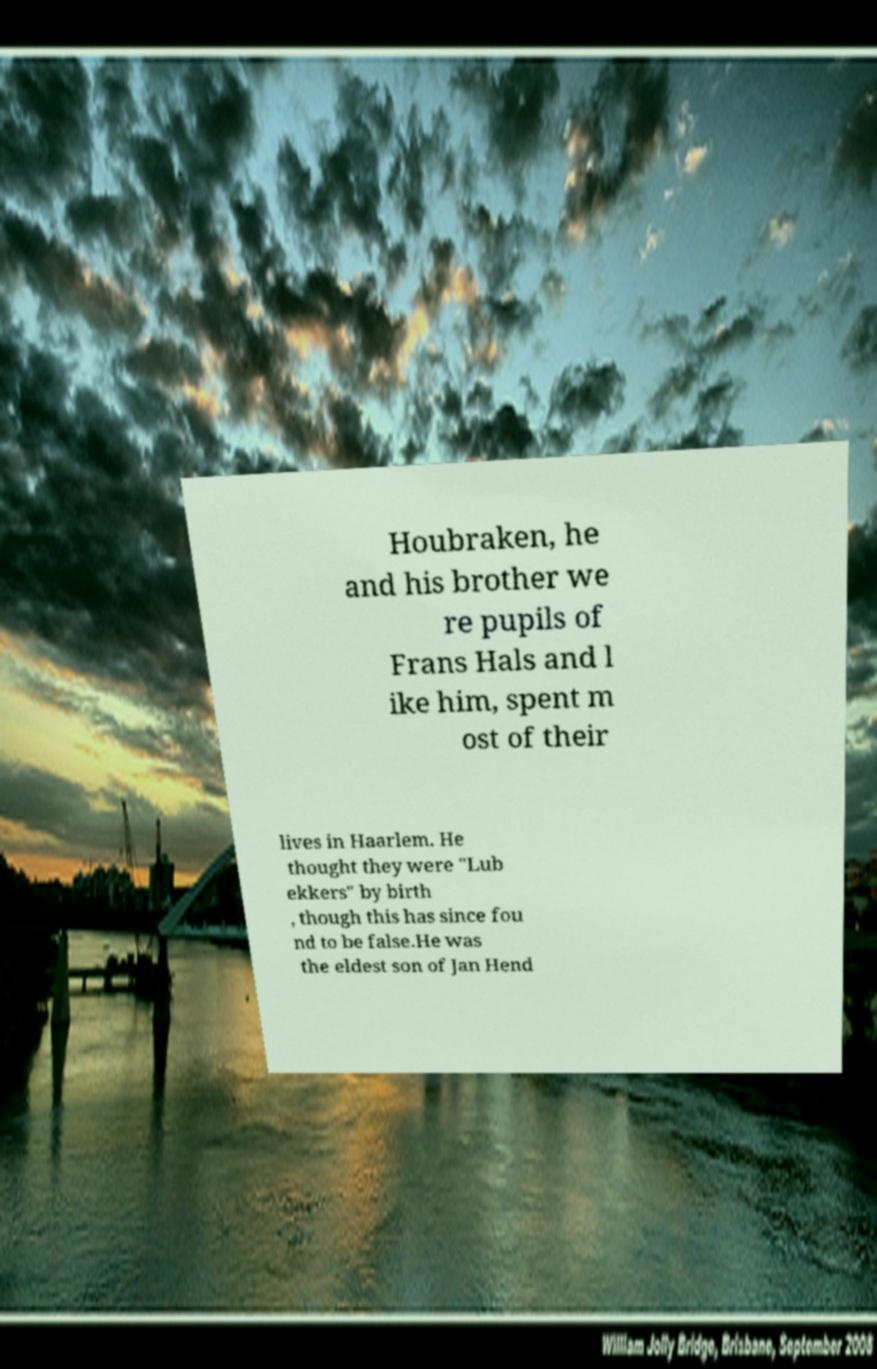What messages or text are displayed in this image? I need them in a readable, typed format. Houbraken, he and his brother we re pupils of Frans Hals and l ike him, spent m ost of their lives in Haarlem. He thought they were "Lub ekkers" by birth , though this has since fou nd to be false.He was the eldest son of Jan Hend 